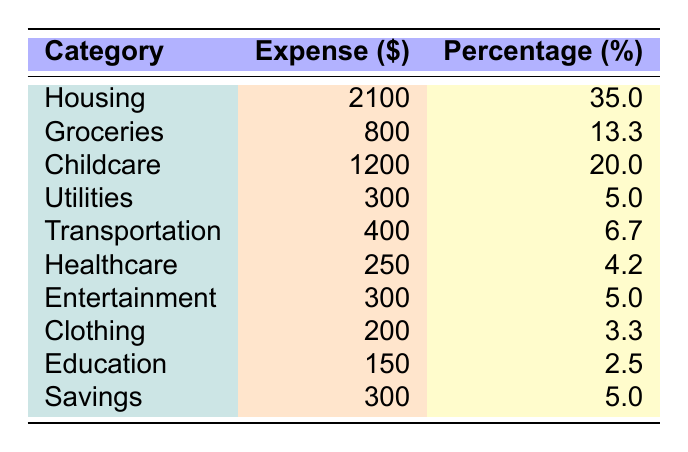What is the total expense for housing? The table shows that the expense for housing is listed as 2100.
Answer: 2100 What percentage of the total household budget is spent on groceries? According to the table, the percentage for groceries is 13.3.
Answer: 13.3% What is the expense for childcare? The expense for childcare listed in the table is 1200.
Answer: 1200 If we sum the expenses for childcare and housing, what is the total? The expense for childcare is 1200 and for housing is 2100. Adding them together gives 1200 + 2100 = 3300.
Answer: 3300 Which category has the highest expense? By examining the table, housing has the highest expense at 2100.
Answer: Housing What is the combined expense for utilities, transportation, and healthcare? Utilities cost 300, transportation costs 400, and healthcare costs 250. Adding these gives 300 + 400 + 250 = 950.
Answer: 950 Is the expense for education more than that for clothing? The expense for education is 150 and for clothing is 200. Since 150 is less than 200, the statement is false.
Answer: No What is the percentage of total income allocated for savings? The savings category in the table is listed as 5%.
Answer: 5% Calculate the average expense for the categories listed in the table. There are 10 categories. The total expense is 2100 + 800 + 1200 + 300 + 400 + 250 + 300 + 200 + 150 + 300 = 5100. The average is 5100 / 10 = 510.
Answer: 510 Which two categories together account for more than 50% of the total budget? Housing (35%) and childcare (20%) make 55%, which is more than 50%.
Answer: Yes 